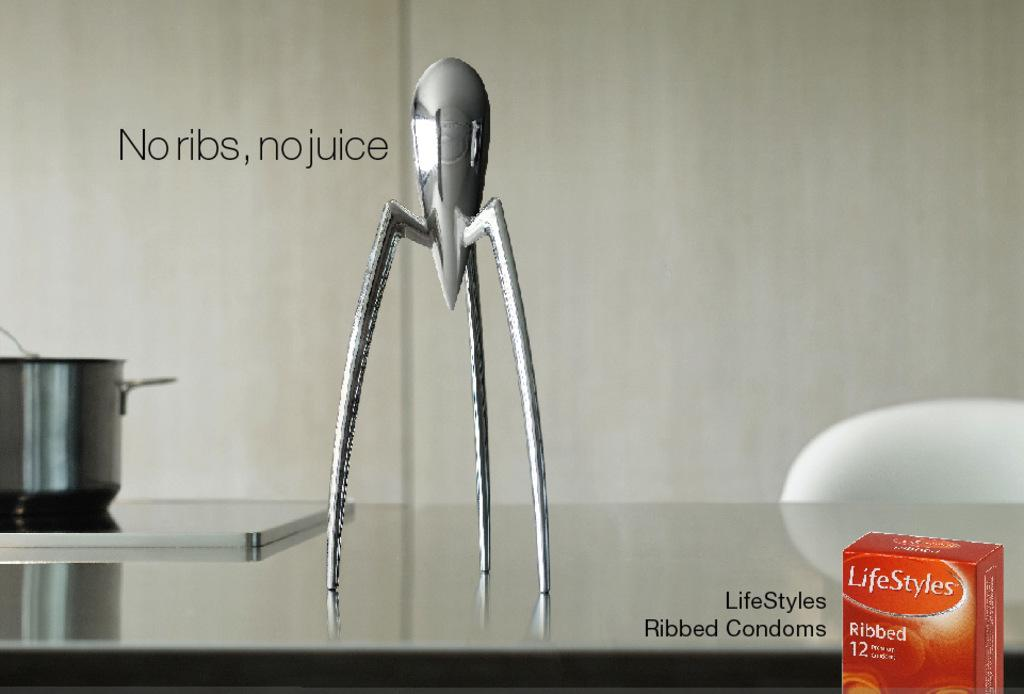<image>
Create a compact narrative representing the image presented. An advertisement for condoms that says no ribs, no juice. 